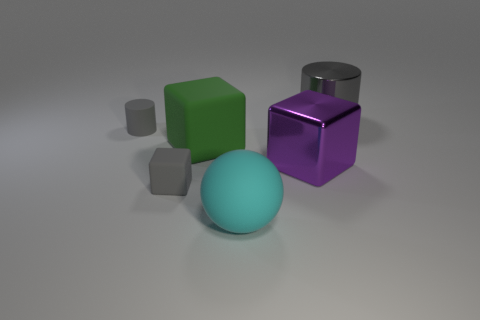Are there any tiny gray matte things of the same shape as the big cyan thing?
Ensure brevity in your answer.  No. What is the shape of the green rubber object that is the same size as the metal cylinder?
Your answer should be compact. Cube. Are there the same number of gray matte cylinders behind the cyan thing and small gray matte cylinders to the right of the large gray metallic thing?
Offer a terse response. No. What is the size of the shiny thing that is behind the cylinder that is left of the cyan object?
Your answer should be compact. Large. Are there any red rubber spheres that have the same size as the metal cylinder?
Your answer should be very brief. No. What color is the thing that is the same material as the large gray cylinder?
Your answer should be very brief. Purple. Is the number of small gray objects less than the number of matte spheres?
Give a very brief answer. No. What is the big object that is right of the large cyan sphere and in front of the shiny cylinder made of?
Offer a terse response. Metal. Is there a green thing that is on the right side of the large block that is on the right side of the cyan matte sphere?
Give a very brief answer. No. What number of small metallic blocks have the same color as the tiny matte cylinder?
Give a very brief answer. 0. 